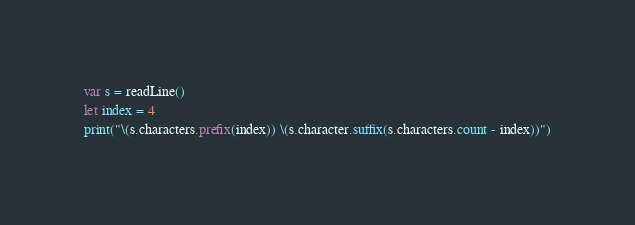Convert code to text. <code><loc_0><loc_0><loc_500><loc_500><_Swift_>var s = readLine()
let index = 4
print("\(s.characters.prefix(index)) \(s.character.suffix(s.characters.count - index))")</code> 